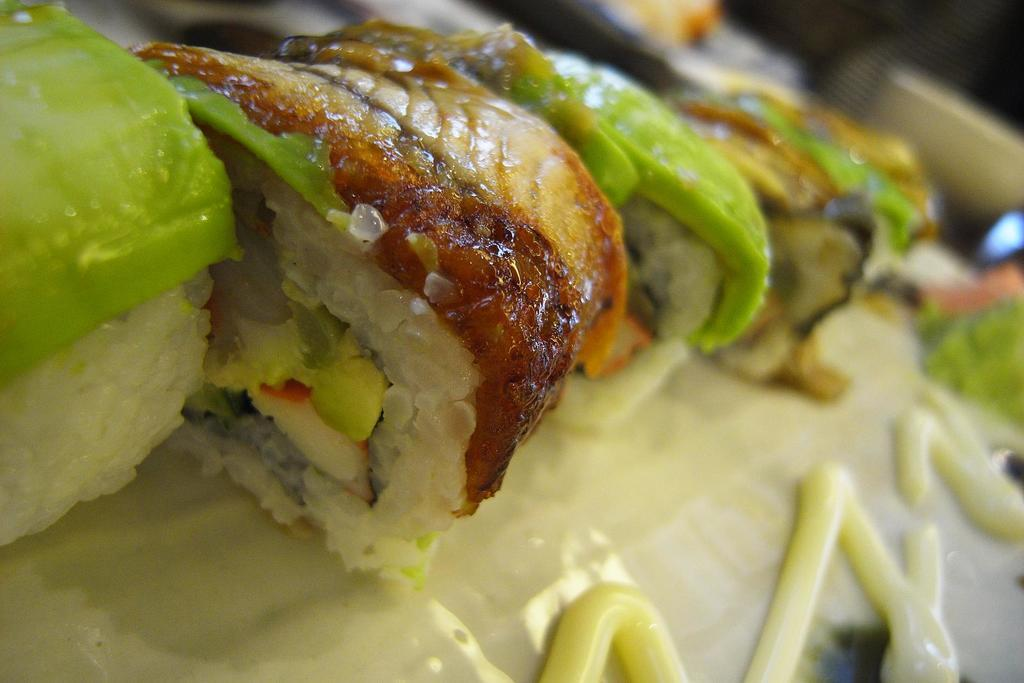What type of ray is depicted on the boundary of the canvas in the image? There is no ray or canvas present in the image, as no specific facts were provided. 